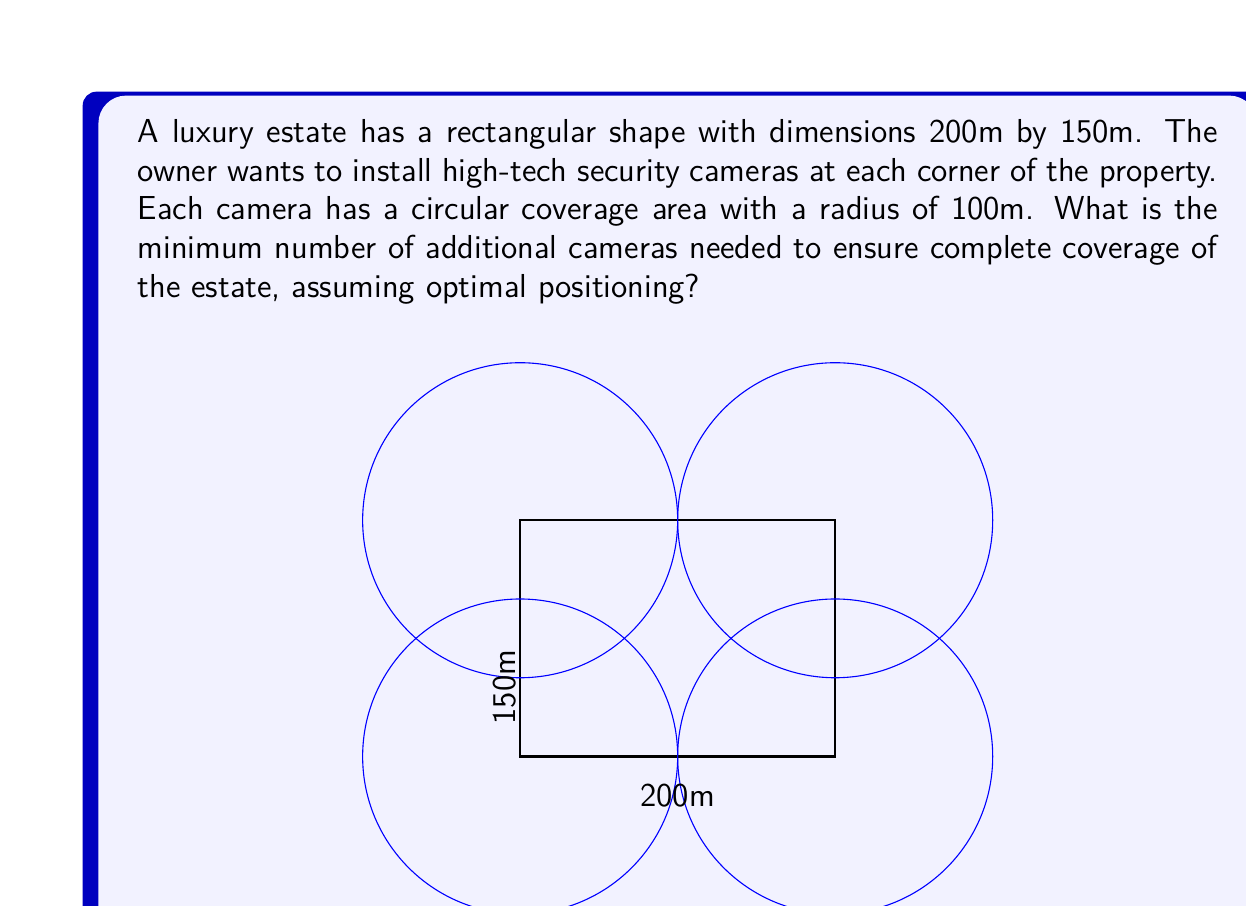Provide a solution to this math problem. Let's approach this step-by-step:

1) First, we need to calculate the area of the estate:
   $$A_{estate} = 200m \times 150m = 30,000m^2$$

2) Next, let's calculate the area covered by the four corner cameras:
   Each camera covers a quarter circle at the corner.
   Area of a quarter circle: $$A_{quarter} = \frac{1}{4} \pi r^2 = \frac{1}{4} \pi (100m)^2 = 2,500\pi m^2$$
   
   Total area covered by four corners: $$A_{corners} = 4 \times 2,500\pi m^2 = 10,000\pi m^2$$

3) The uncovered area is:
   $$A_{uncovered} = A_{estate} - A_{corners} = 30,000m^2 - 10,000\pi m^2 \approx 1,416m^2$$

4) Each additional camera, if optimally placed, can cover a full circle:
   $$A_{camera} = \pi r^2 = \pi (100m)^2 = 10,000\pi m^2 \approx 31,416m^2$$

5) The number of additional cameras needed is:
   $$N = \lceil\frac{A_{uncovered}}{A_{camera}}\rceil = \lceil\frac{1,416}{31,416}\rceil = 1$$

Therefore, only one additional camera is needed, optimally placed in the center of the estate, to ensure complete coverage.
Answer: 1 additional camera 